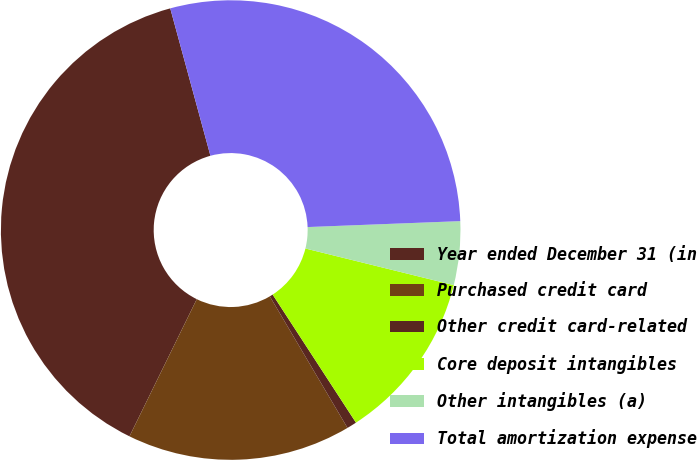<chart> <loc_0><loc_0><loc_500><loc_500><pie_chart><fcel>Year ended December 31 (in<fcel>Purchased credit card<fcel>Other credit card-related<fcel>Core deposit intangibles<fcel>Other intangibles (a)<fcel>Total amortization expense<nl><fcel>38.51%<fcel>15.75%<fcel>0.69%<fcel>11.97%<fcel>4.47%<fcel>28.62%<nl></chart> 